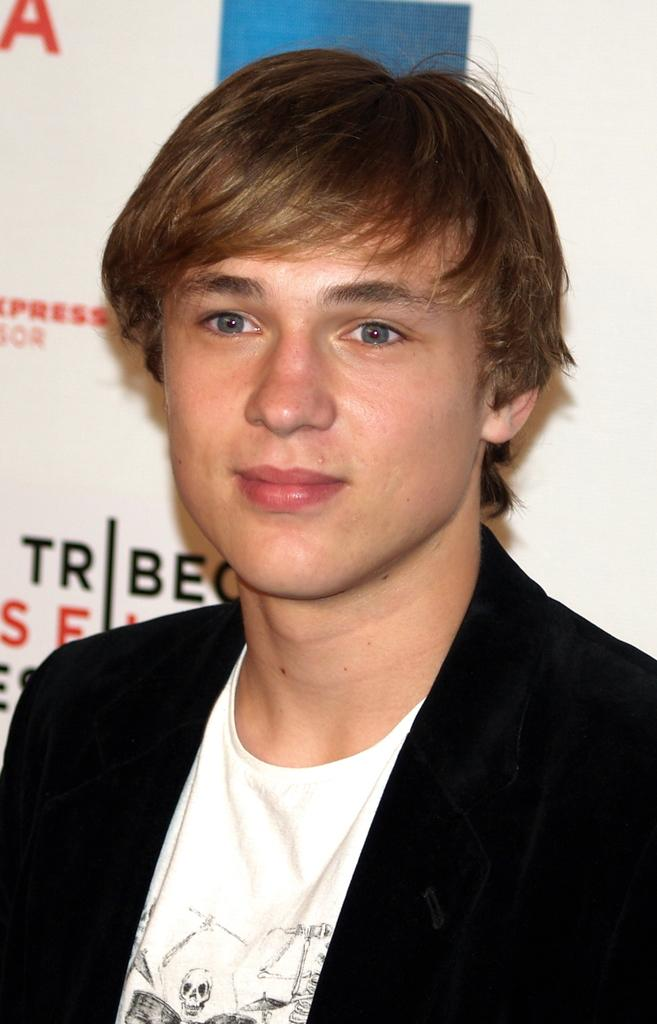Who is the main subject in the image? There is a man in the image. What is the man wearing? The man is wearing a black blazer. What is behind the man in the image? There is a board behind the man. What can be seen on the board? There is text on the board. How is the man's expression in the image? The man is smiling. How many eyes does the man have in the image? The man has two eyes in the image. What is the measurement of the board behind the man? The facts provided do not include any information about the size or measurement of the board. 